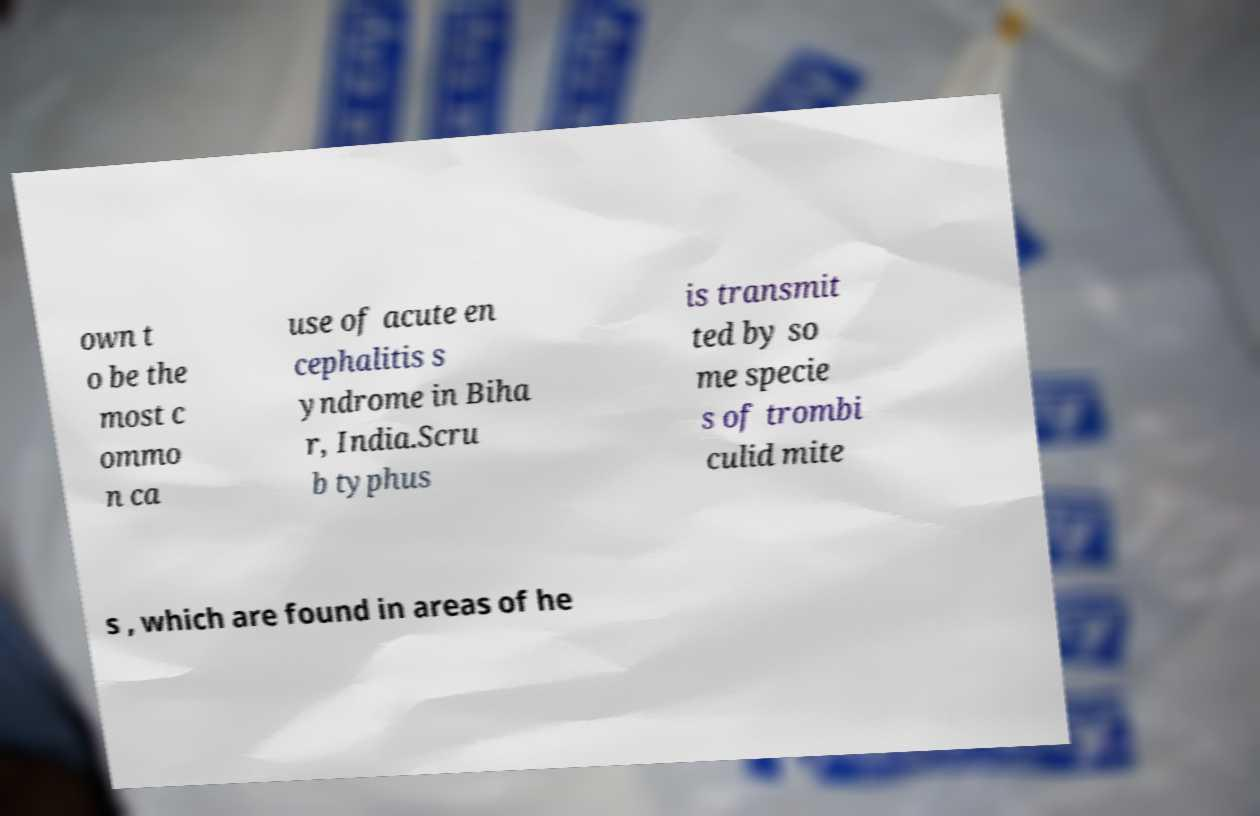For documentation purposes, I need the text within this image transcribed. Could you provide that? own t o be the most c ommo n ca use of acute en cephalitis s yndrome in Biha r, India.Scru b typhus is transmit ted by so me specie s of trombi culid mite s , which are found in areas of he 